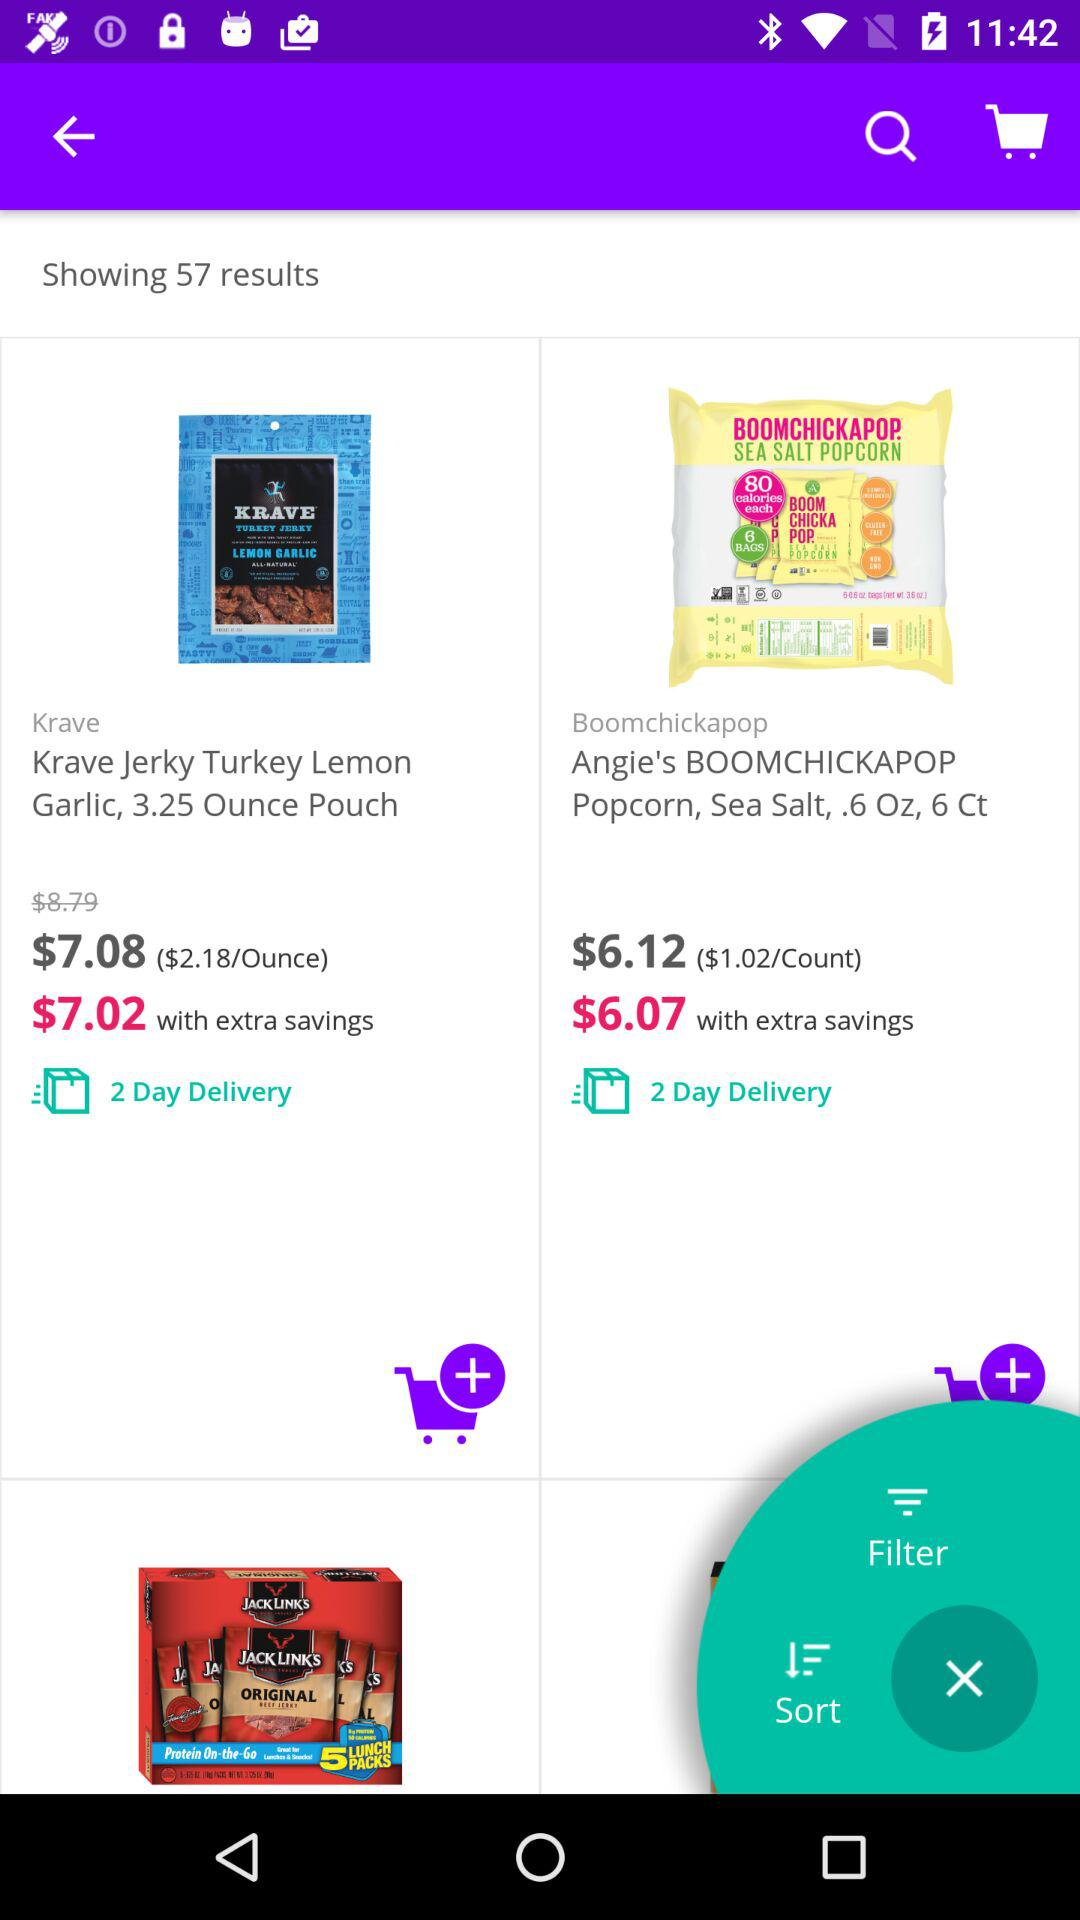How many results are shown? There are 57 results shown. 